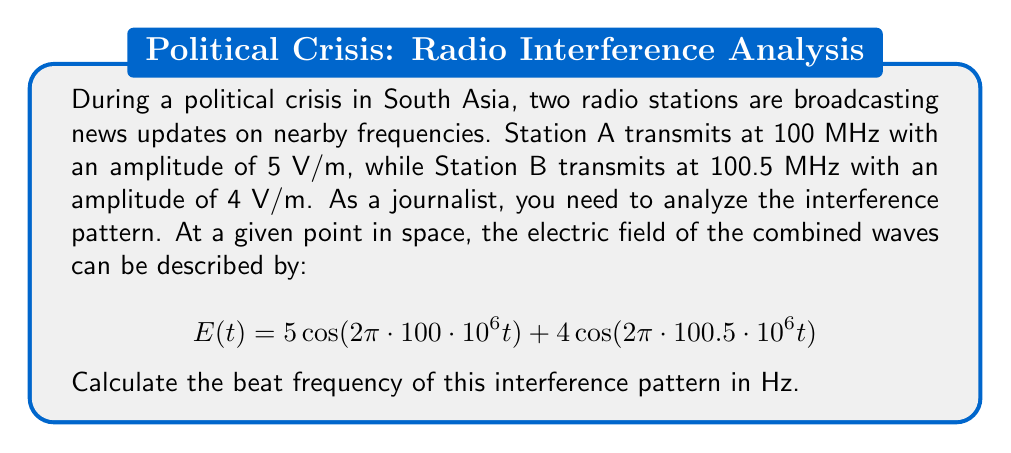Teach me how to tackle this problem. To solve this problem, we'll follow these steps:

1) The beat frequency is the difference between the two frequencies of the interfering waves.

2) Station A's frequency: $f_1 = 100$ MHz = $100 \cdot 10^6$ Hz
   Station B's frequency: $f_2 = 100.5$ MHz = $100.5 \cdot 10^6$ Hz

3) The beat frequency $f_b$ is given by:
   $$f_b = |f_2 - f_1|$$

4) Substituting the values:
   $$f_b = |100.5 \cdot 10^6 - 100 \cdot 10^6|$$

5) Simplifying:
   $$f_b = |0.5 \cdot 10^6|$$

6) Evaluating:
   $$f_b = 0.5 \cdot 10^6 = 500,000\text{ Hz}$$

Therefore, the beat frequency is 500,000 Hz or 500 kHz.
Answer: 500 kHz 